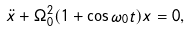<formula> <loc_0><loc_0><loc_500><loc_500>\ddot { x } + \Omega _ { 0 } ^ { 2 } ( 1 + \cos \omega _ { 0 } t ) x = 0 ,</formula> 